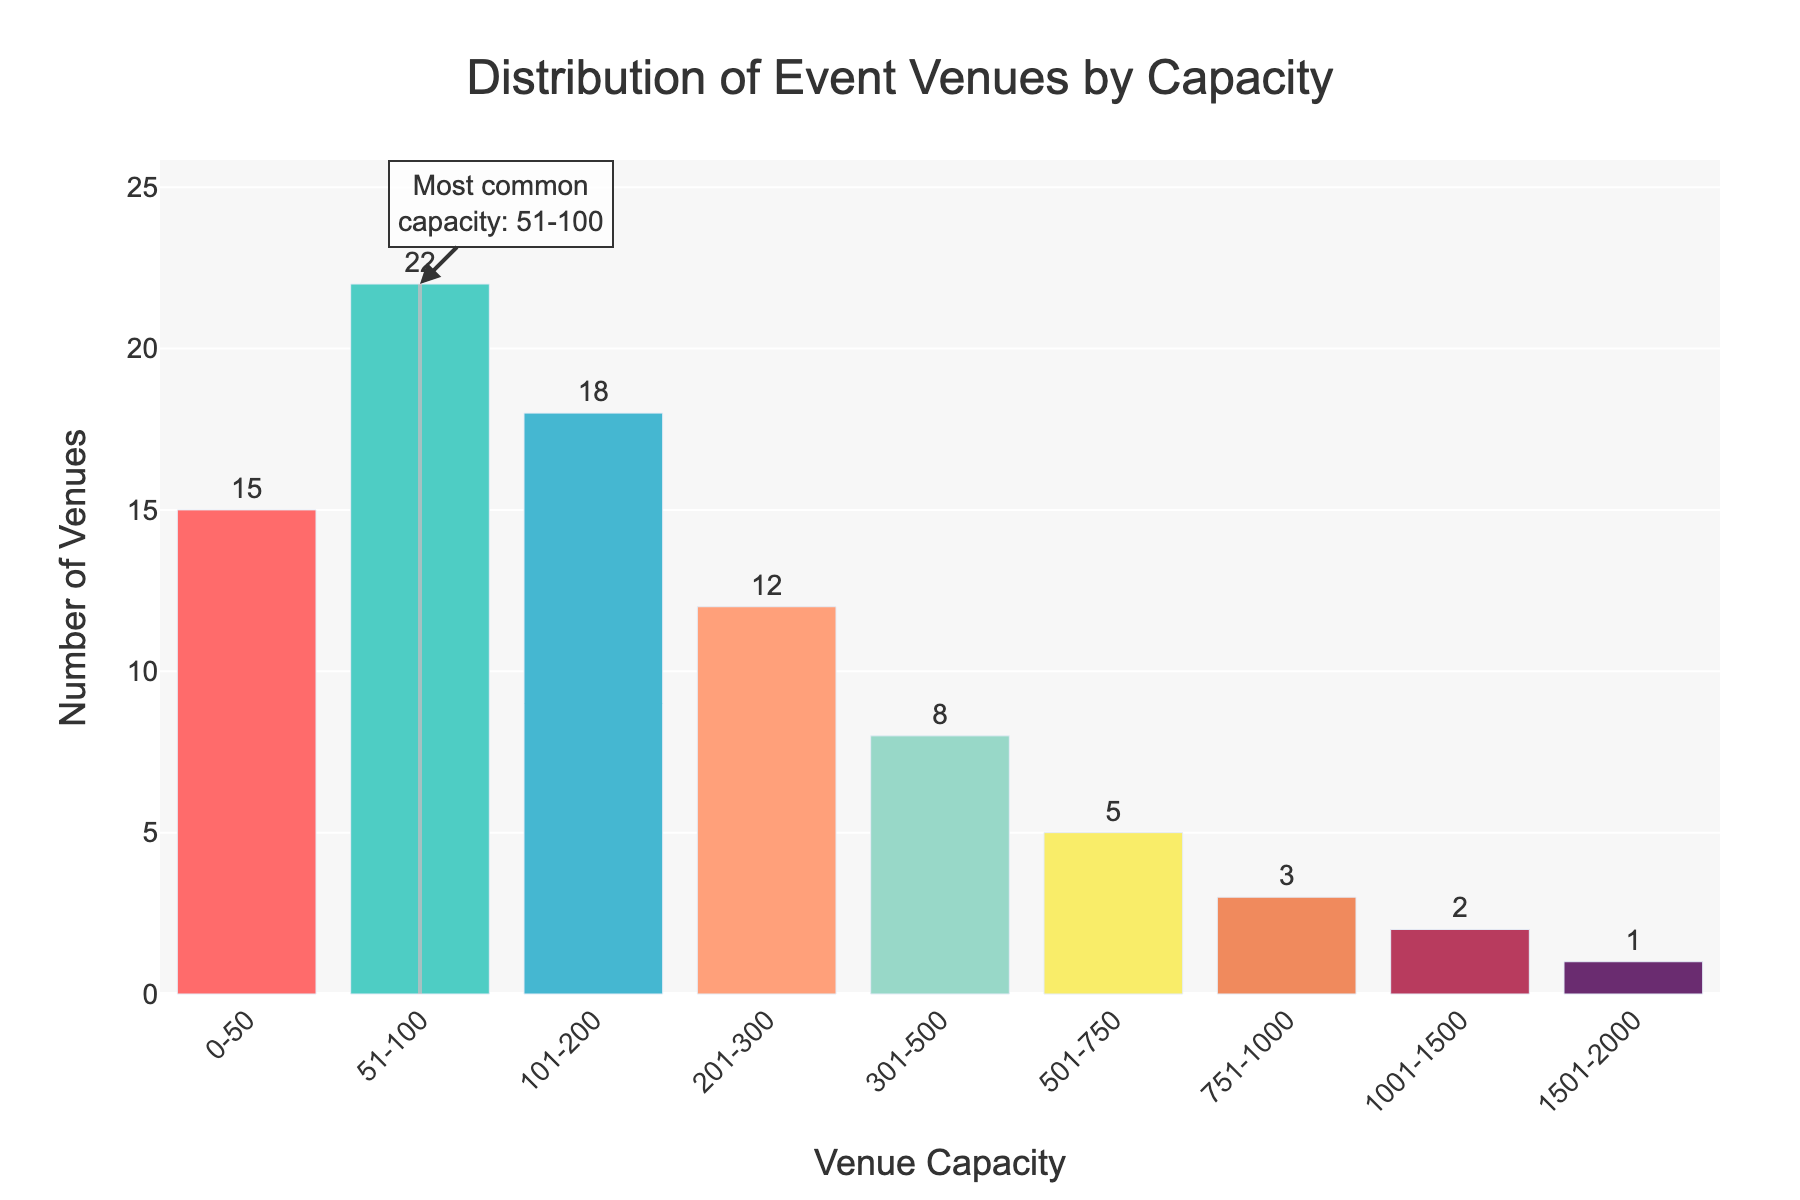What's the most common venue capacity range? The figure highlights the most common venue capacity range with a rectangle and annotation. The capacity range with the highest number of venues is "51-100".
Answer: 51-100 Which venue capacity range has the least number of venues? By analyzing the heights of the bars in the figure, we can see that the capacity range "1501-2000" has the shortest bar, indicating it has the least number of venues.
Answer: 1501-2000 How many venues have a capacity greater than 1000? By summing the number of venues for the capacity ranges "1001-1500" and "1501-2000", we get 2 + 1 = 3 venues.
Answer: 3 What is the total number of venues shown in the figure? Adding up the number of venues: 15 + 22 + 18 + 12 + 8 + 5 + 3 + 2 + 1 = 86.
Answer: 86 Is the number of venues with a capacity of 0-50 greater than the number of venues with a capacity of 201-300? The figure shows that there are 15 venues with a capacity of 0-50 and 12 venues with a capacity of 201-300. Since 15 is greater than 12, the answer is yes.
Answer: Yes What is the difference in the number of venues between the capacity range of 51-100 and 501-750? The number of venues for 51-100 is 22 and for 501-750 is 5. The difference is 22 - 5 = 17.
Answer: 17 Which venue capacity ranges have an equal number of venues? Examining the figure, "1001-1500" and "1501-2000" have 2 and 1 venues respectively, no ranges have equal venues.
Answer: None What is the average number of venues for capacities ranging from 101 to 500? The capacity ranges from 101-200, 201-300, and 301-500 have 18, 12, and 8 venues, respectively. The sum is 18 + 12 + 8 = 38. The average is 38 / 3 = 12.67.
Answer: 12.67 What color is used for the bar representing the most common venue capacity range? The figure highlights the bar for the venue capacity range 51-100 in turquoise/green color.
Answer: Turquoise/green 